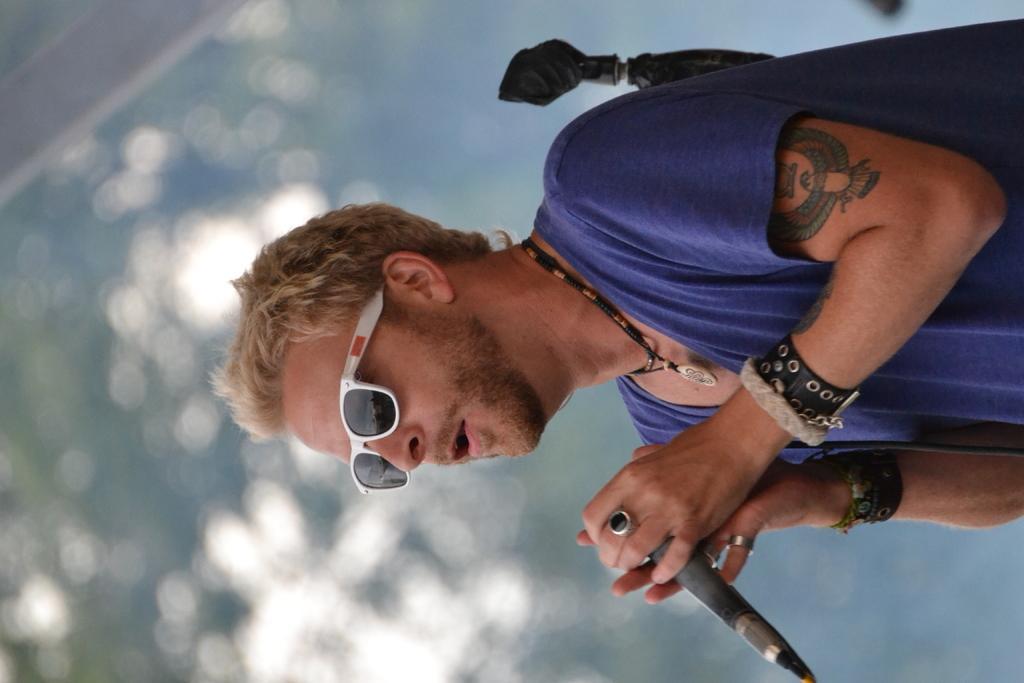Could you give a brief overview of what you see in this image? In this image we can see a man holding a mike with his hands and he wore goggles. There is a blur background. 